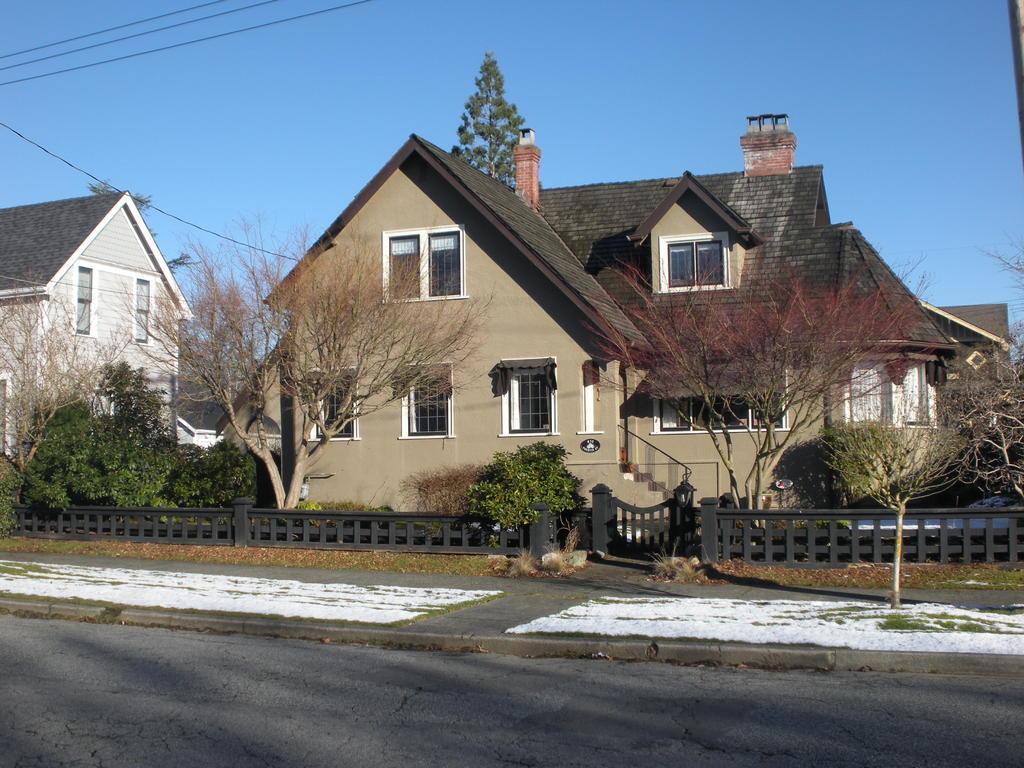Could you give a brief overview of what you see in this image? In this picture I can see buildings, trees and I can see fence and a blue sky. 